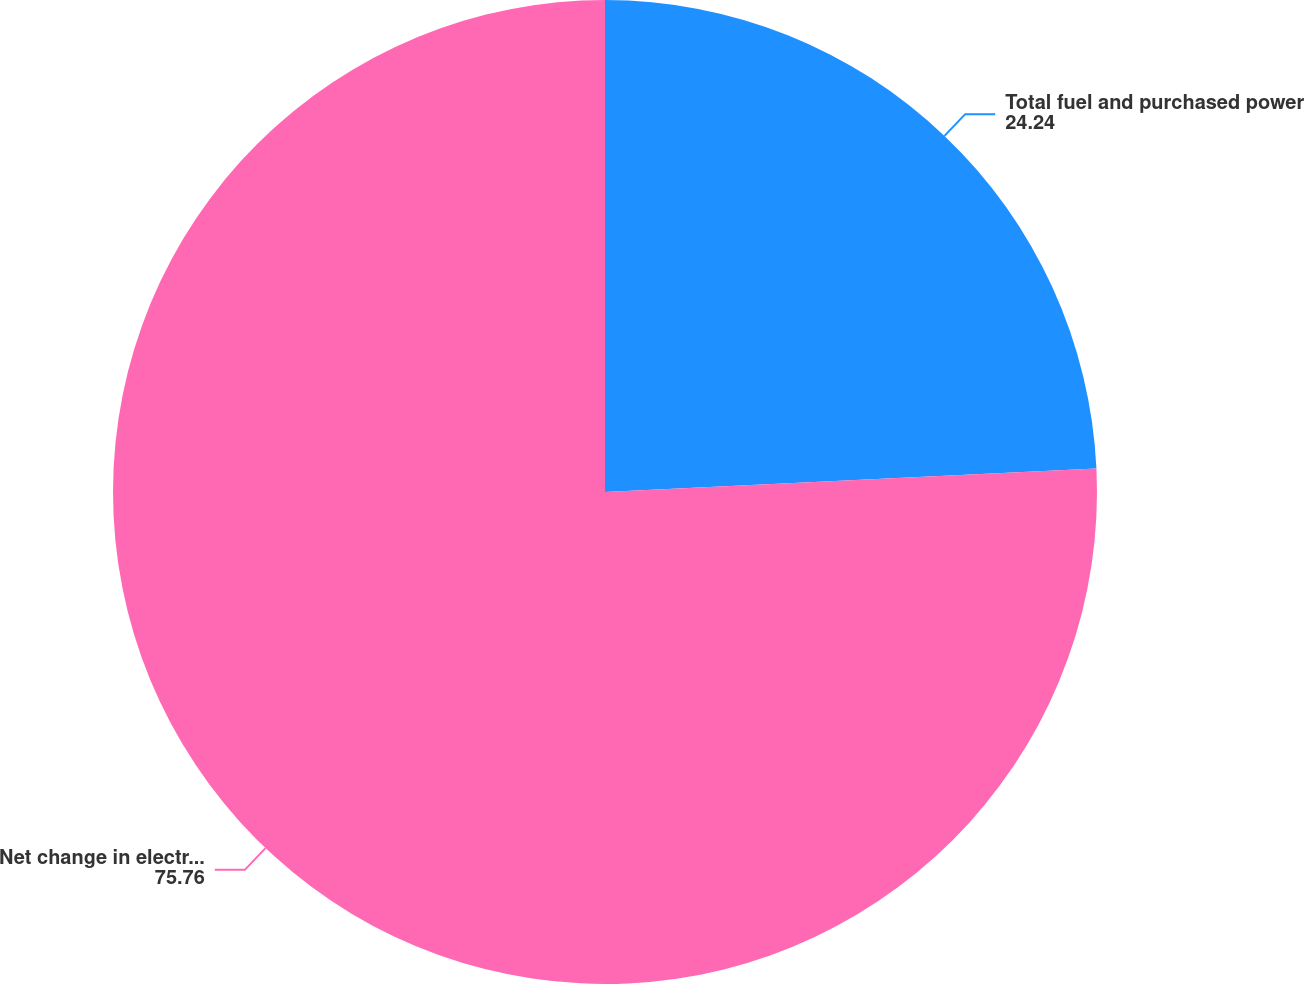Convert chart. <chart><loc_0><loc_0><loc_500><loc_500><pie_chart><fcel>Total fuel and purchased power<fcel>Net change in electric margins<nl><fcel>24.24%<fcel>75.76%<nl></chart> 